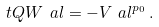Convert formula to latex. <formula><loc_0><loc_0><loc_500><loc_500>\ t Q W _ { \ } a l = - V _ { \ } a l ^ { p _ { 0 } } \, .</formula> 